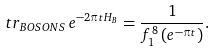Convert formula to latex. <formula><loc_0><loc_0><loc_500><loc_500>t r _ { B O S O N S } \, e ^ { - 2 \pi t H _ { B } } = \frac { 1 } { f _ { 1 } ^ { 8 } \left ( e ^ { - \pi t } \right ) } .</formula> 